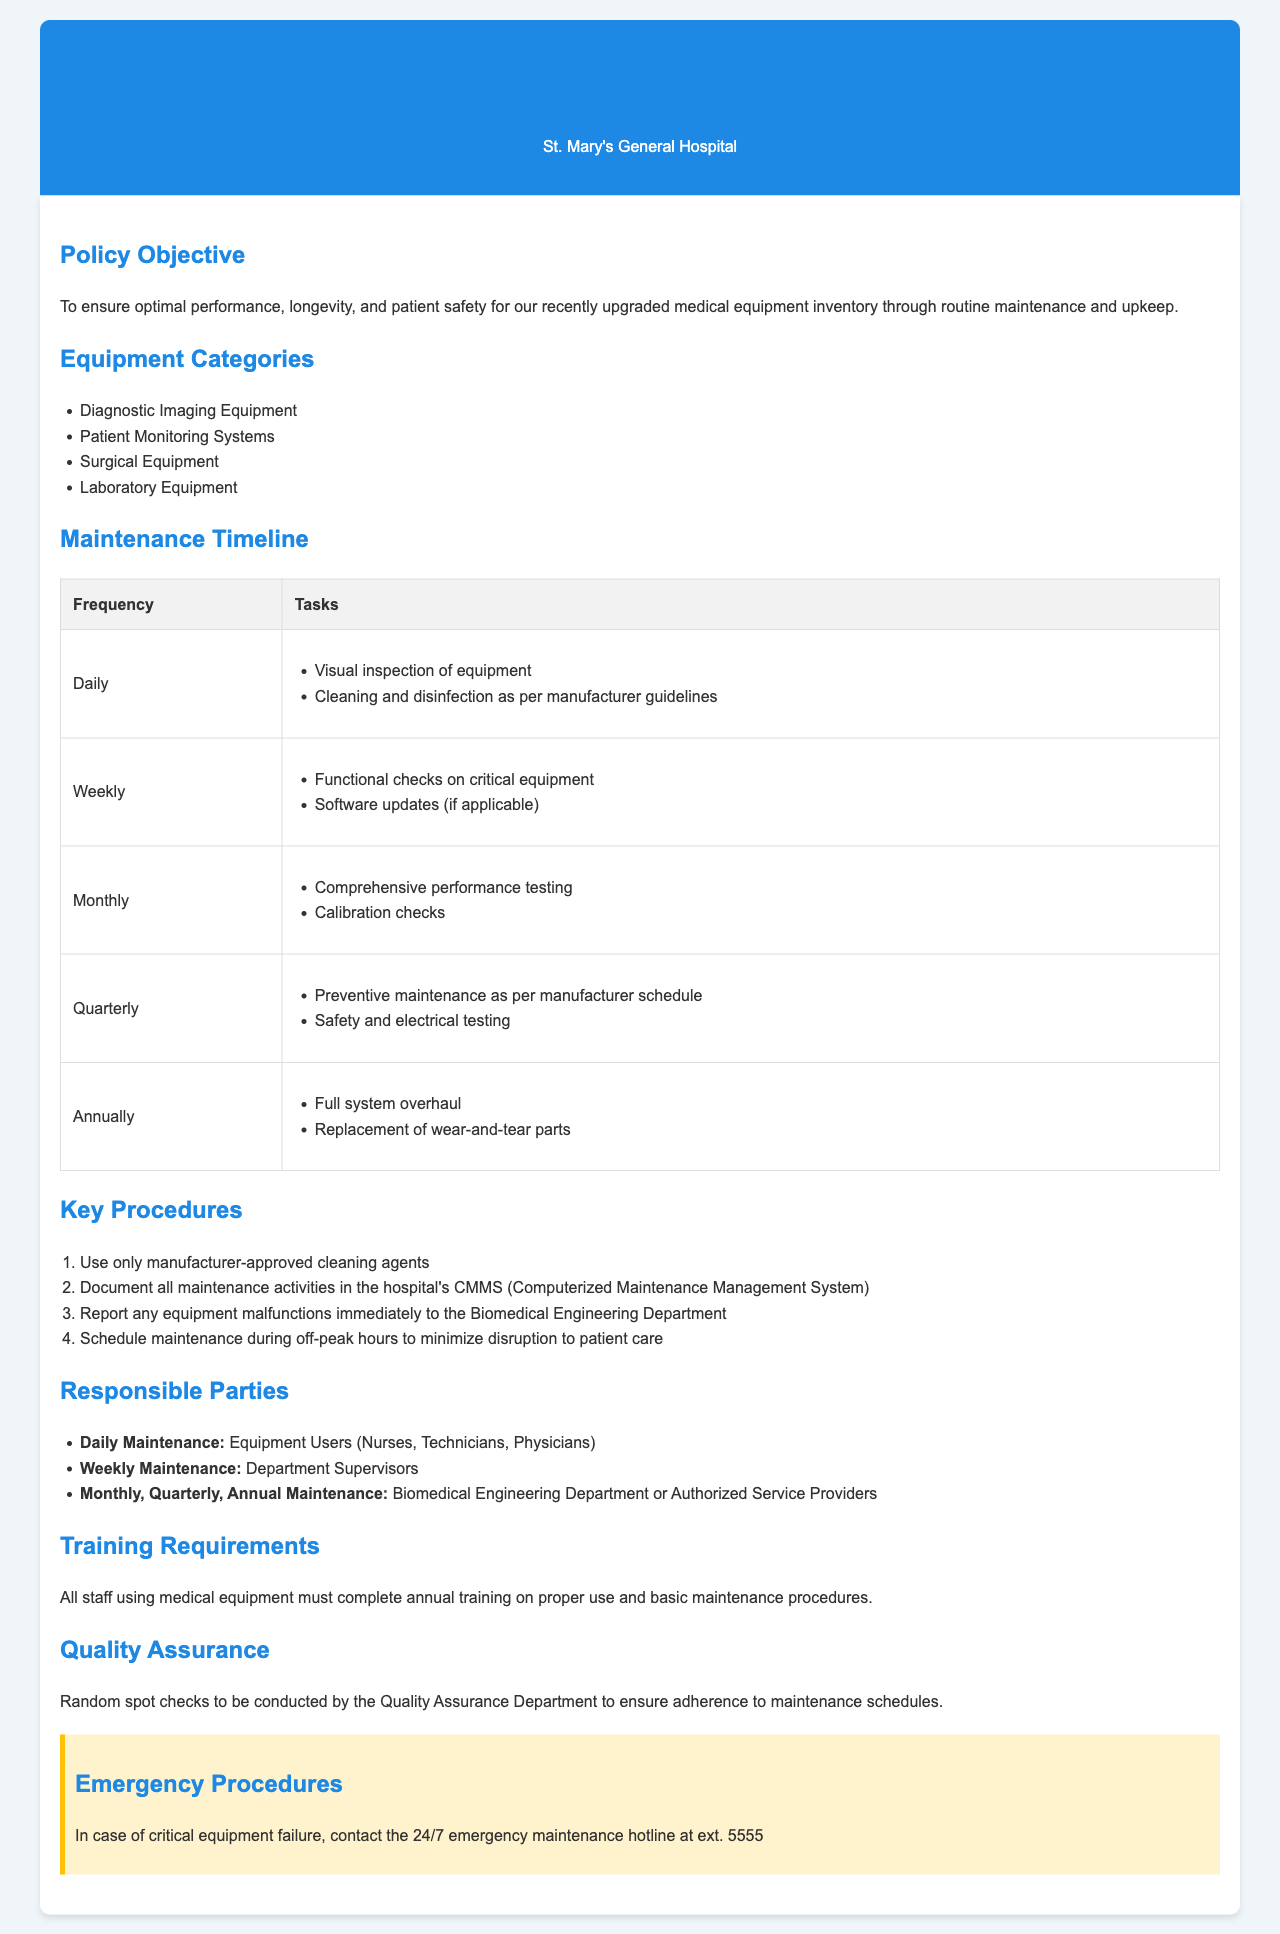What is the policy objective? The policy objective outlines the aim of the maintenance schedule, which is to ensure optimal performance, longevity, and patient safety of the upgraded medical equipment.
Answer: To ensure optimal performance, longevity, and patient safety for our recently upgraded medical equipment inventory through routine maintenance and upkeep How often is comprehensive performance testing conducted? The maintenance timeline indicates that comprehensive performance testing is done on a monthly basis.
Answer: Monthly Who is responsible for daily maintenance? The document specifies that equipment users such as nurses, technicians, and physicians are responsible for daily maintenance.
Answer: Equipment Users (Nurses, Technicians, Physicians) What is the frequency for preventive maintenance? The document states that preventive maintenance is scheduled quarterly according to the manufacturer's specifications.
Answer: Quarterly What type of training must all staff complete? The training requirements section indicates that all staff using medical equipment must complete annual training.
Answer: Annual training Which department conducts random spot checks? The quality assurance section mentions that the Quality Assurance Department is responsible for conducting random spot checks.
Answer: Quality Assurance Department What should be used for cleaning according to the procedures? According to the key procedures, only manufacturer-approved cleaning agents should be used.
Answer: Manufacturer-approved cleaning agents How frequently are safety and electrical testing performed? The maintenance timeline specifies that safety and electrical testing is performed on a quarterly basis.
Answer: Quarterly What is the emergency maintenance hotline extension? In the emergency procedures section, the document provides the hotline extension for critical equipment failure.
Answer: ext. 5555 